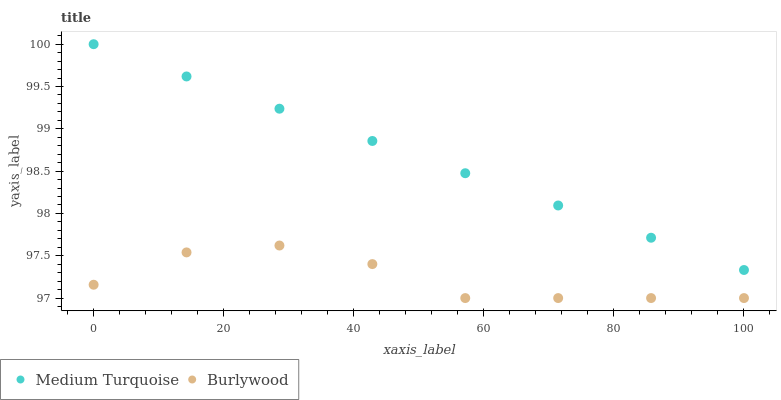Does Burlywood have the minimum area under the curve?
Answer yes or no. Yes. Does Medium Turquoise have the maximum area under the curve?
Answer yes or no. Yes. Does Medium Turquoise have the minimum area under the curve?
Answer yes or no. No. Is Medium Turquoise the smoothest?
Answer yes or no. Yes. Is Burlywood the roughest?
Answer yes or no. Yes. Is Medium Turquoise the roughest?
Answer yes or no. No. Does Burlywood have the lowest value?
Answer yes or no. Yes. Does Medium Turquoise have the lowest value?
Answer yes or no. No. Does Medium Turquoise have the highest value?
Answer yes or no. Yes. Is Burlywood less than Medium Turquoise?
Answer yes or no. Yes. Is Medium Turquoise greater than Burlywood?
Answer yes or no. Yes. Does Burlywood intersect Medium Turquoise?
Answer yes or no. No. 